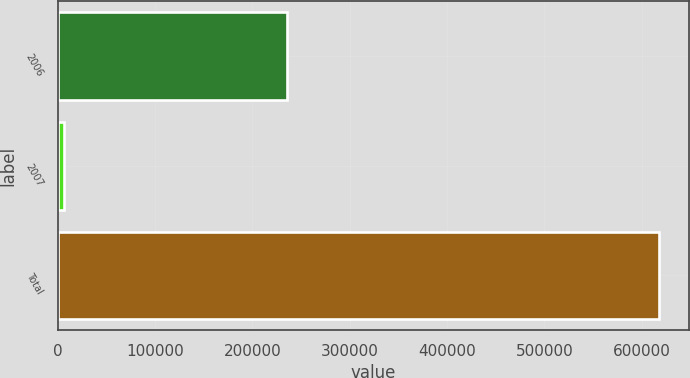Convert chart. <chart><loc_0><loc_0><loc_500><loc_500><bar_chart><fcel>2006<fcel>2007<fcel>Total<nl><fcel>235717<fcel>7053<fcel>617827<nl></chart> 